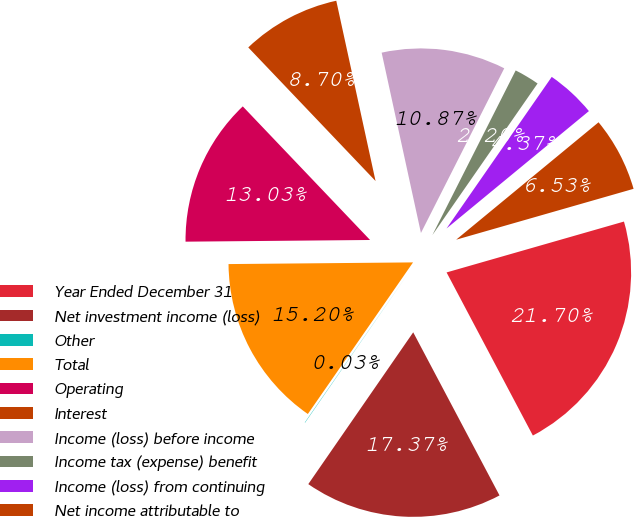<chart> <loc_0><loc_0><loc_500><loc_500><pie_chart><fcel>Year Ended December 31<fcel>Net investment income (loss)<fcel>Other<fcel>Total<fcel>Operating<fcel>Interest<fcel>Income (loss) before income<fcel>Income tax (expense) benefit<fcel>Income (loss) from continuing<fcel>Net income attributable to<nl><fcel>21.7%<fcel>17.37%<fcel>0.03%<fcel>15.2%<fcel>13.03%<fcel>8.7%<fcel>10.87%<fcel>2.2%<fcel>4.37%<fcel>6.53%<nl></chart> 